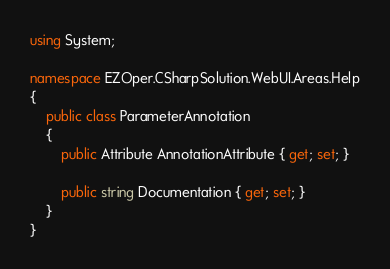<code> <loc_0><loc_0><loc_500><loc_500><_C#_>using System;

namespace EZOper.CSharpSolution.WebUI.Areas.Help
{
    public class ParameterAnnotation
    {
        public Attribute AnnotationAttribute { get; set; }

        public string Documentation { get; set; }
    }
}</code> 